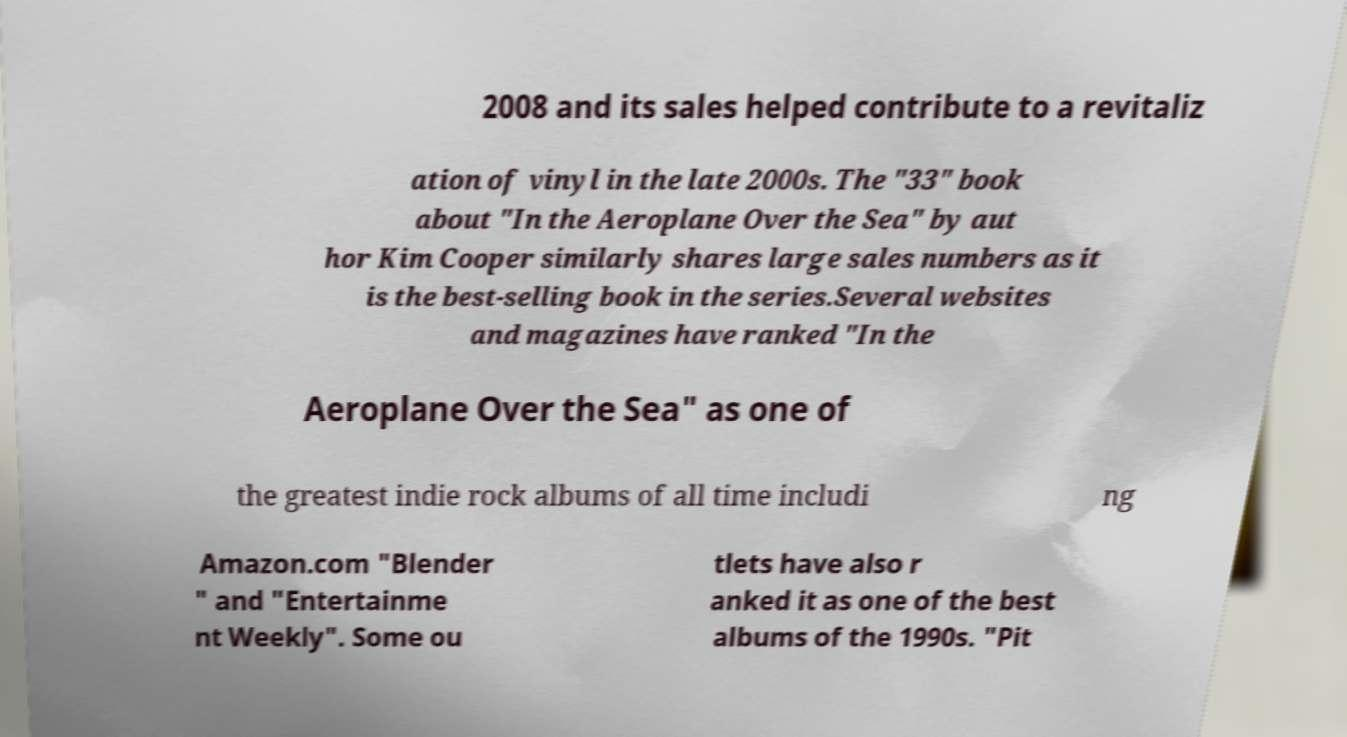I need the written content from this picture converted into text. Can you do that? 2008 and its sales helped contribute to a revitaliz ation of vinyl in the late 2000s. The "33" book about "In the Aeroplane Over the Sea" by aut hor Kim Cooper similarly shares large sales numbers as it is the best-selling book in the series.Several websites and magazines have ranked "In the Aeroplane Over the Sea" as one of the greatest indie rock albums of all time includi ng Amazon.com "Blender " and "Entertainme nt Weekly". Some ou tlets have also r anked it as one of the best albums of the 1990s. "Pit 